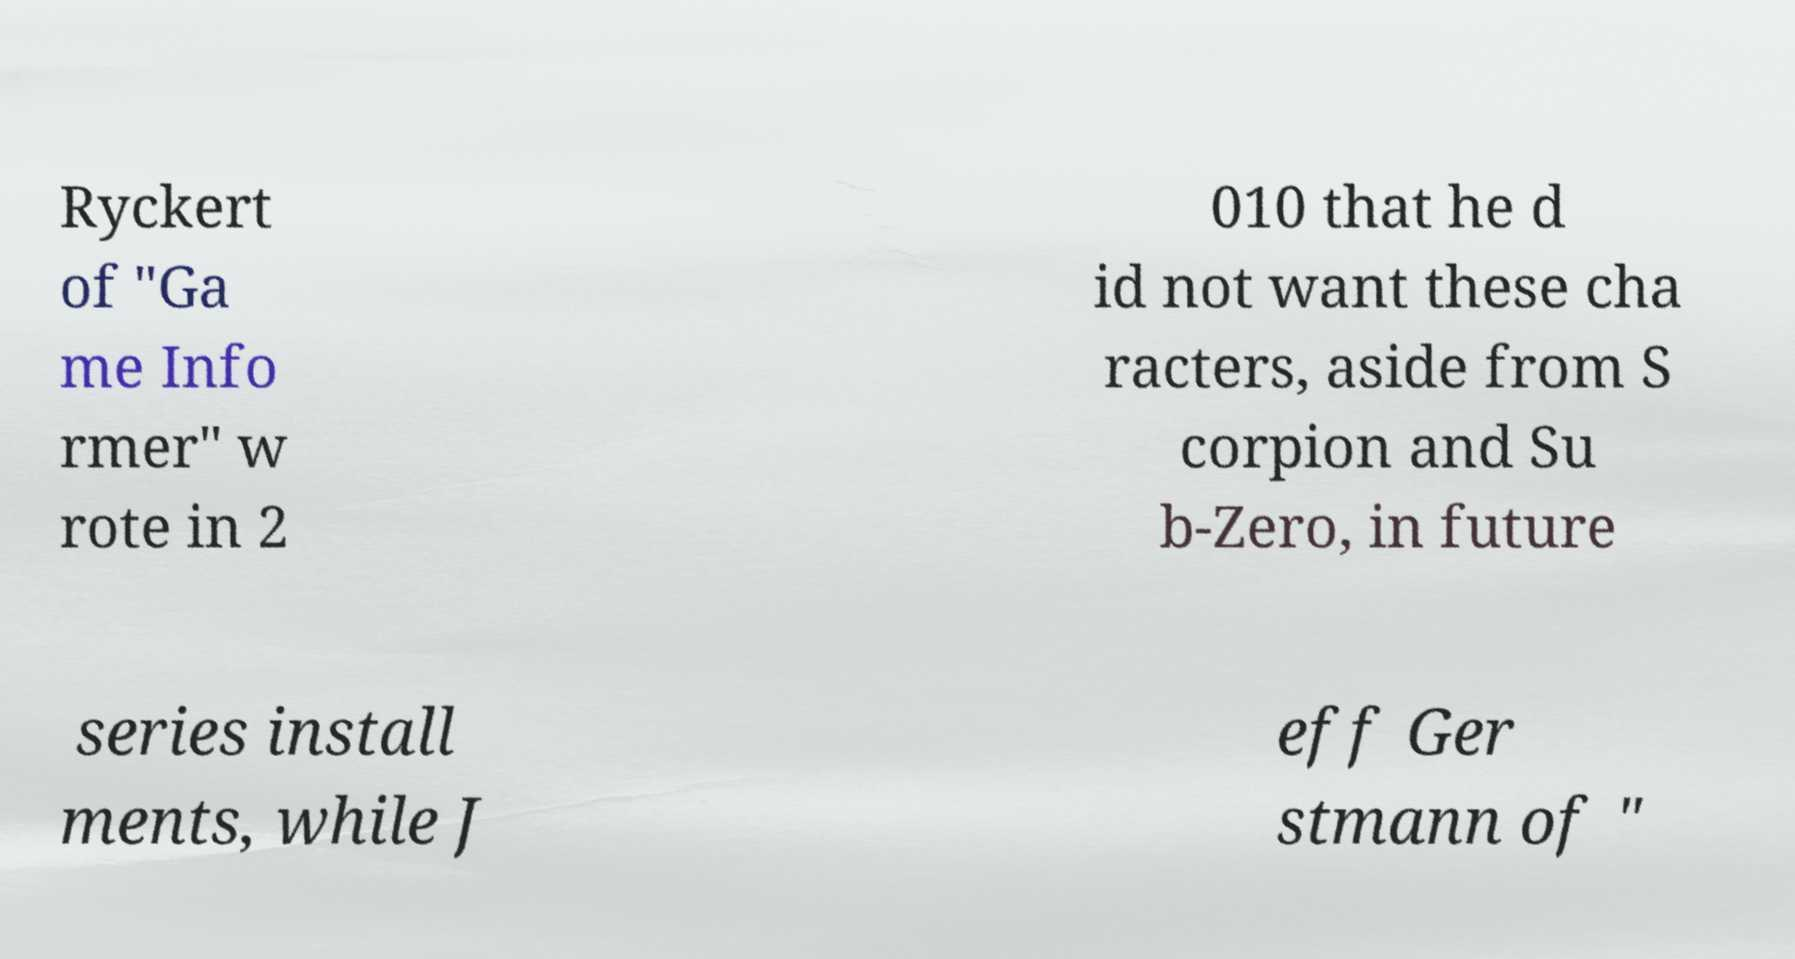Please read and relay the text visible in this image. What does it say? Ryckert of "Ga me Info rmer" w rote in 2 010 that he d id not want these cha racters, aside from S corpion and Su b-Zero, in future series install ments, while J eff Ger stmann of " 